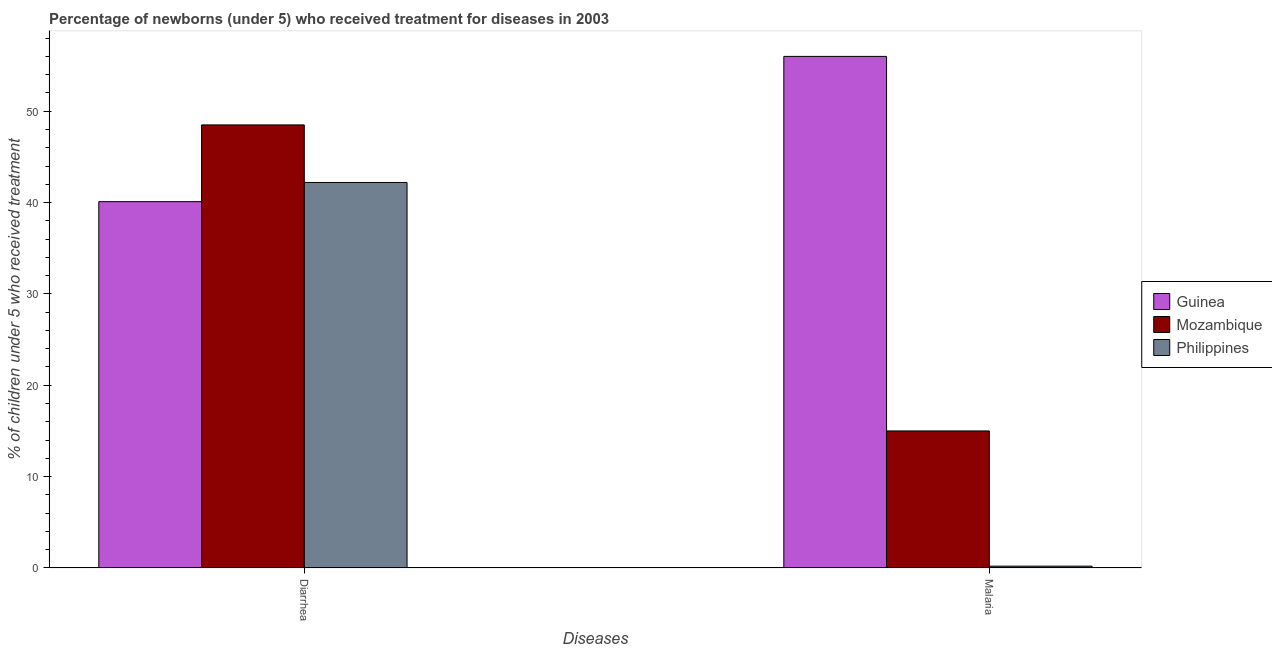How many different coloured bars are there?
Offer a terse response. 3. Are the number of bars per tick equal to the number of legend labels?
Your answer should be compact. Yes. How many bars are there on the 1st tick from the left?
Offer a very short reply. 3. How many bars are there on the 1st tick from the right?
Ensure brevity in your answer.  3. What is the label of the 1st group of bars from the left?
Provide a short and direct response. Diarrhea. What is the percentage of children who received treatment for malaria in Mozambique?
Keep it short and to the point. 15. Across all countries, what is the maximum percentage of children who received treatment for diarrhoea?
Ensure brevity in your answer.  48.5. In which country was the percentage of children who received treatment for diarrhoea maximum?
Provide a short and direct response. Mozambique. In which country was the percentage of children who received treatment for malaria minimum?
Ensure brevity in your answer.  Philippines. What is the total percentage of children who received treatment for malaria in the graph?
Make the answer very short. 71.2. What is the difference between the percentage of children who received treatment for diarrhoea in Guinea and that in Philippines?
Your answer should be compact. -2.1. What is the average percentage of children who received treatment for malaria per country?
Give a very brief answer. 23.73. What is the difference between the percentage of children who received treatment for malaria and percentage of children who received treatment for diarrhoea in Mozambique?
Ensure brevity in your answer.  -33.5. In how many countries, is the percentage of children who received treatment for diarrhoea greater than 34 %?
Provide a short and direct response. 3. What is the ratio of the percentage of children who received treatment for malaria in Mozambique to that in Guinea?
Offer a very short reply. 0.27. Is the percentage of children who received treatment for diarrhoea in Guinea less than that in Mozambique?
Keep it short and to the point. Yes. In how many countries, is the percentage of children who received treatment for malaria greater than the average percentage of children who received treatment for malaria taken over all countries?
Your answer should be very brief. 1. What does the 2nd bar from the left in Malaria represents?
Provide a short and direct response. Mozambique. Are the values on the major ticks of Y-axis written in scientific E-notation?
Provide a short and direct response. No. Where does the legend appear in the graph?
Your answer should be compact. Center right. How many legend labels are there?
Provide a succinct answer. 3. What is the title of the graph?
Your answer should be compact. Percentage of newborns (under 5) who received treatment for diseases in 2003. What is the label or title of the X-axis?
Ensure brevity in your answer.  Diseases. What is the label or title of the Y-axis?
Your answer should be very brief. % of children under 5 who received treatment. What is the % of children under 5 who received treatment of Guinea in Diarrhea?
Your answer should be compact. 40.1. What is the % of children under 5 who received treatment of Mozambique in Diarrhea?
Offer a very short reply. 48.5. What is the % of children under 5 who received treatment of Philippines in Diarrhea?
Your answer should be very brief. 42.2. What is the % of children under 5 who received treatment of Mozambique in Malaria?
Make the answer very short. 15. Across all Diseases, what is the maximum % of children under 5 who received treatment of Mozambique?
Your answer should be very brief. 48.5. Across all Diseases, what is the maximum % of children under 5 who received treatment of Philippines?
Offer a terse response. 42.2. Across all Diseases, what is the minimum % of children under 5 who received treatment in Guinea?
Keep it short and to the point. 40.1. What is the total % of children under 5 who received treatment of Guinea in the graph?
Ensure brevity in your answer.  96.1. What is the total % of children under 5 who received treatment in Mozambique in the graph?
Your response must be concise. 63.5. What is the total % of children under 5 who received treatment in Philippines in the graph?
Provide a succinct answer. 42.4. What is the difference between the % of children under 5 who received treatment in Guinea in Diarrhea and that in Malaria?
Your response must be concise. -15.9. What is the difference between the % of children under 5 who received treatment in Mozambique in Diarrhea and that in Malaria?
Make the answer very short. 33.5. What is the difference between the % of children under 5 who received treatment of Philippines in Diarrhea and that in Malaria?
Keep it short and to the point. 42. What is the difference between the % of children under 5 who received treatment in Guinea in Diarrhea and the % of children under 5 who received treatment in Mozambique in Malaria?
Provide a succinct answer. 25.1. What is the difference between the % of children under 5 who received treatment in Guinea in Diarrhea and the % of children under 5 who received treatment in Philippines in Malaria?
Your answer should be very brief. 39.9. What is the difference between the % of children under 5 who received treatment in Mozambique in Diarrhea and the % of children under 5 who received treatment in Philippines in Malaria?
Your response must be concise. 48.3. What is the average % of children under 5 who received treatment in Guinea per Diseases?
Your answer should be very brief. 48.05. What is the average % of children under 5 who received treatment in Mozambique per Diseases?
Provide a short and direct response. 31.75. What is the average % of children under 5 who received treatment in Philippines per Diseases?
Ensure brevity in your answer.  21.2. What is the difference between the % of children under 5 who received treatment in Guinea and % of children under 5 who received treatment in Mozambique in Malaria?
Keep it short and to the point. 41. What is the difference between the % of children under 5 who received treatment of Guinea and % of children under 5 who received treatment of Philippines in Malaria?
Offer a very short reply. 55.8. What is the difference between the % of children under 5 who received treatment of Mozambique and % of children under 5 who received treatment of Philippines in Malaria?
Make the answer very short. 14.8. What is the ratio of the % of children under 5 who received treatment in Guinea in Diarrhea to that in Malaria?
Make the answer very short. 0.72. What is the ratio of the % of children under 5 who received treatment in Mozambique in Diarrhea to that in Malaria?
Your answer should be very brief. 3.23. What is the ratio of the % of children under 5 who received treatment in Philippines in Diarrhea to that in Malaria?
Keep it short and to the point. 211. What is the difference between the highest and the second highest % of children under 5 who received treatment of Guinea?
Offer a terse response. 15.9. What is the difference between the highest and the second highest % of children under 5 who received treatment of Mozambique?
Give a very brief answer. 33.5. What is the difference between the highest and the second highest % of children under 5 who received treatment of Philippines?
Your answer should be compact. 42. What is the difference between the highest and the lowest % of children under 5 who received treatment in Guinea?
Ensure brevity in your answer.  15.9. What is the difference between the highest and the lowest % of children under 5 who received treatment of Mozambique?
Provide a short and direct response. 33.5. 